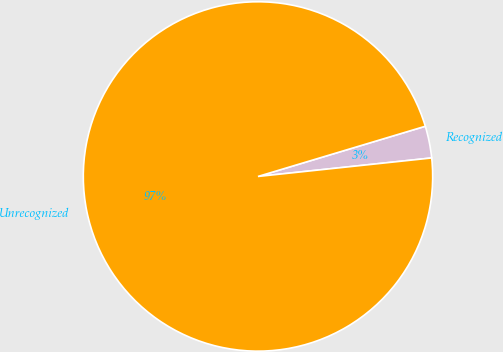Convert chart. <chart><loc_0><loc_0><loc_500><loc_500><pie_chart><fcel>Recognized<fcel>Unrecognized<nl><fcel>2.95%<fcel>97.05%<nl></chart> 